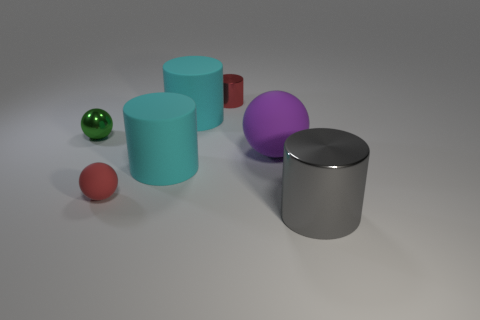Add 3 tiny shiny objects. How many objects exist? 10 Subtract all small balls. How many balls are left? 1 Subtract all red cubes. How many cyan cylinders are left? 2 Subtract all cylinders. How many objects are left? 3 Subtract 1 balls. How many balls are left? 2 Subtract all purple balls. How many balls are left? 2 Subtract all brown balls. Subtract all red blocks. How many balls are left? 3 Subtract all purple shiny things. Subtract all large cyan matte cylinders. How many objects are left? 5 Add 2 red matte things. How many red matte things are left? 3 Add 2 purple rubber things. How many purple rubber things exist? 3 